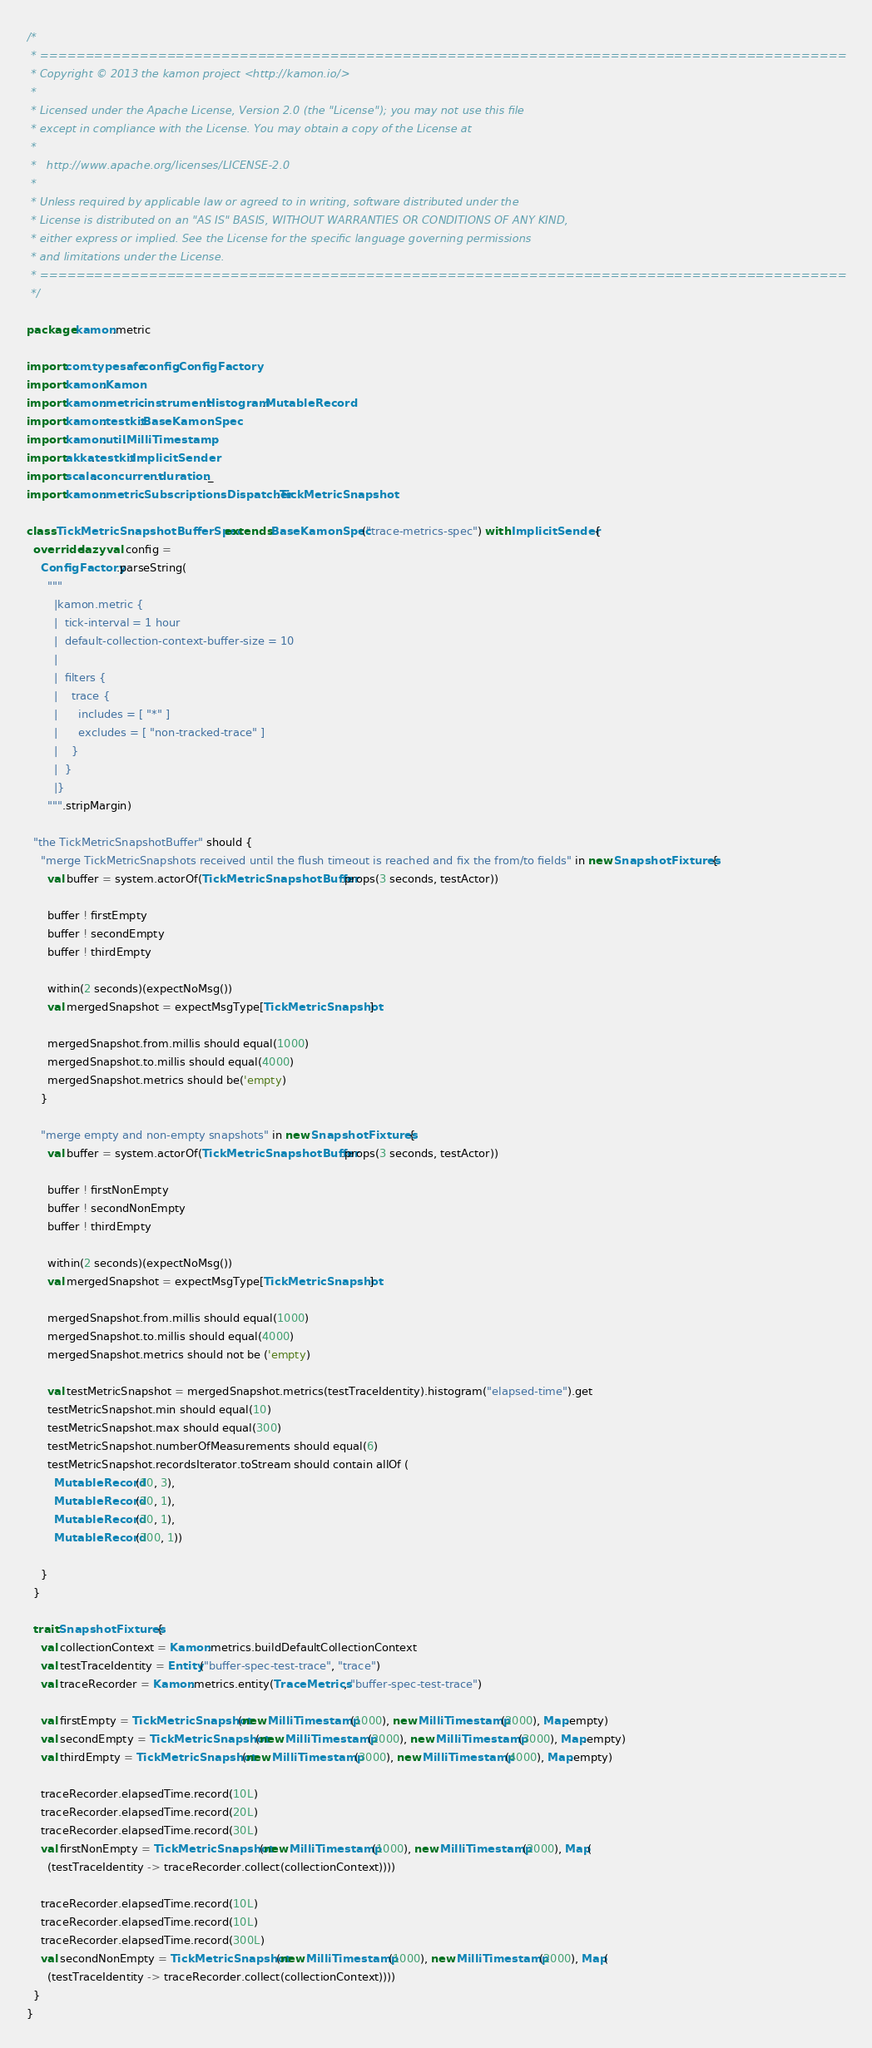<code> <loc_0><loc_0><loc_500><loc_500><_Scala_>/*
 * =========================================================================================
 * Copyright © 2013 the kamon project <http://kamon.io/>
 *
 * Licensed under the Apache License, Version 2.0 (the "License"); you may not use this file
 * except in compliance with the License. You may obtain a copy of the License at
 *
 *   http://www.apache.org/licenses/LICENSE-2.0
 *
 * Unless required by applicable law or agreed to in writing, software distributed under the
 * License is distributed on an "AS IS" BASIS, WITHOUT WARRANTIES OR CONDITIONS OF ANY KIND,
 * either express or implied. See the License for the specific language governing permissions
 * and limitations under the License.
 * =========================================================================================
 */

package kamon.metric

import com.typesafe.config.ConfigFactory
import kamon.Kamon
import kamon.metric.instrument.Histogram.MutableRecord
import kamon.testkit.BaseKamonSpec
import kamon.util.MilliTimestamp
import akka.testkit.ImplicitSender
import scala.concurrent.duration._
import kamon.metric.SubscriptionsDispatcher.TickMetricSnapshot

class TickMetricSnapshotBufferSpec extends BaseKamonSpec("trace-metrics-spec") with ImplicitSender {
  override lazy val config =
    ConfigFactory.parseString(
      """
        |kamon.metric {
        |  tick-interval = 1 hour
        |  default-collection-context-buffer-size = 10
        |
        |  filters {
        |    trace {
        |      includes = [ "*" ]
        |      excludes = [ "non-tracked-trace" ]
        |    }
        |  }
        |}
      """.stripMargin)

  "the TickMetricSnapshotBuffer" should {
    "merge TickMetricSnapshots received until the flush timeout is reached and fix the from/to fields" in new SnapshotFixtures {
      val buffer = system.actorOf(TickMetricSnapshotBuffer.props(3 seconds, testActor))

      buffer ! firstEmpty
      buffer ! secondEmpty
      buffer ! thirdEmpty

      within(2 seconds)(expectNoMsg())
      val mergedSnapshot = expectMsgType[TickMetricSnapshot]

      mergedSnapshot.from.millis should equal(1000)
      mergedSnapshot.to.millis should equal(4000)
      mergedSnapshot.metrics should be('empty)
    }

    "merge empty and non-empty snapshots" in new SnapshotFixtures {
      val buffer = system.actorOf(TickMetricSnapshotBuffer.props(3 seconds, testActor))

      buffer ! firstNonEmpty
      buffer ! secondNonEmpty
      buffer ! thirdEmpty

      within(2 seconds)(expectNoMsg())
      val mergedSnapshot = expectMsgType[TickMetricSnapshot]

      mergedSnapshot.from.millis should equal(1000)
      mergedSnapshot.to.millis should equal(4000)
      mergedSnapshot.metrics should not be ('empty)

      val testMetricSnapshot = mergedSnapshot.metrics(testTraceIdentity).histogram("elapsed-time").get
      testMetricSnapshot.min should equal(10)
      testMetricSnapshot.max should equal(300)
      testMetricSnapshot.numberOfMeasurements should equal(6)
      testMetricSnapshot.recordsIterator.toStream should contain allOf (
        MutableRecord(10, 3),
        MutableRecord(20, 1),
        MutableRecord(30, 1),
        MutableRecord(300, 1))

    }
  }

  trait SnapshotFixtures {
    val collectionContext = Kamon.metrics.buildDefaultCollectionContext
    val testTraceIdentity = Entity("buffer-spec-test-trace", "trace")
    val traceRecorder = Kamon.metrics.entity(TraceMetrics, "buffer-spec-test-trace")

    val firstEmpty = TickMetricSnapshot(new MilliTimestamp(1000), new MilliTimestamp(2000), Map.empty)
    val secondEmpty = TickMetricSnapshot(new MilliTimestamp(2000), new MilliTimestamp(3000), Map.empty)
    val thirdEmpty = TickMetricSnapshot(new MilliTimestamp(3000), new MilliTimestamp(4000), Map.empty)

    traceRecorder.elapsedTime.record(10L)
    traceRecorder.elapsedTime.record(20L)
    traceRecorder.elapsedTime.record(30L)
    val firstNonEmpty = TickMetricSnapshot(new MilliTimestamp(1000), new MilliTimestamp(2000), Map(
      (testTraceIdentity -> traceRecorder.collect(collectionContext))))

    traceRecorder.elapsedTime.record(10L)
    traceRecorder.elapsedTime.record(10L)
    traceRecorder.elapsedTime.record(300L)
    val secondNonEmpty = TickMetricSnapshot(new MilliTimestamp(1000), new MilliTimestamp(2000), Map(
      (testTraceIdentity -> traceRecorder.collect(collectionContext))))
  }
}
</code> 